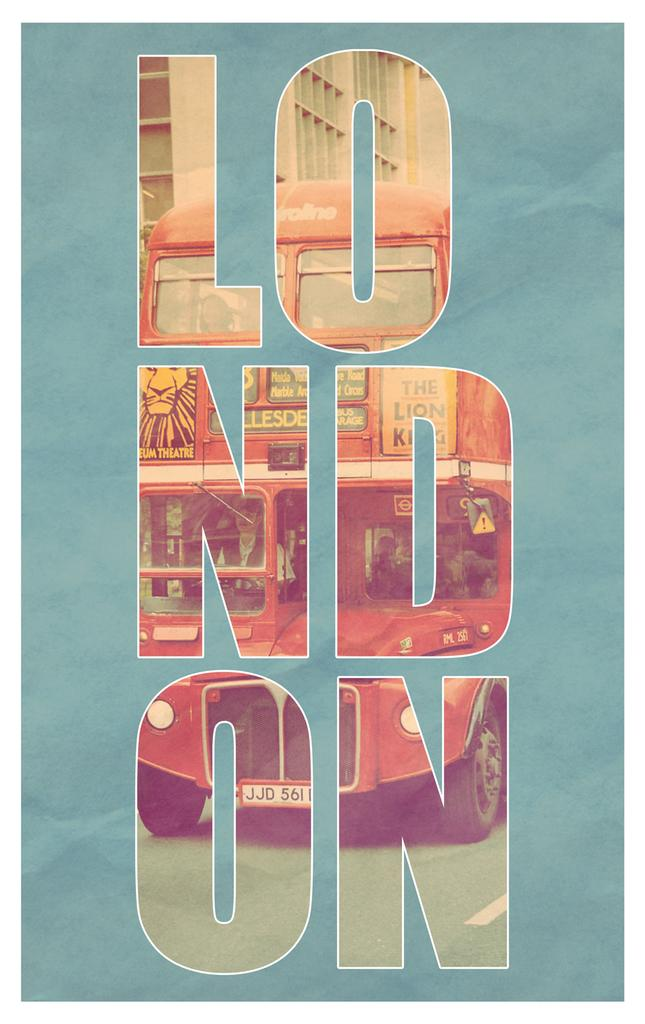What can be found in the image? There is text in the image. What is the color of the surface on which the text is written? The text is on a blue surface. What scent is associated with the text in the image? There is no mention of a scent in the image, as it only contains text on a blue surface. 